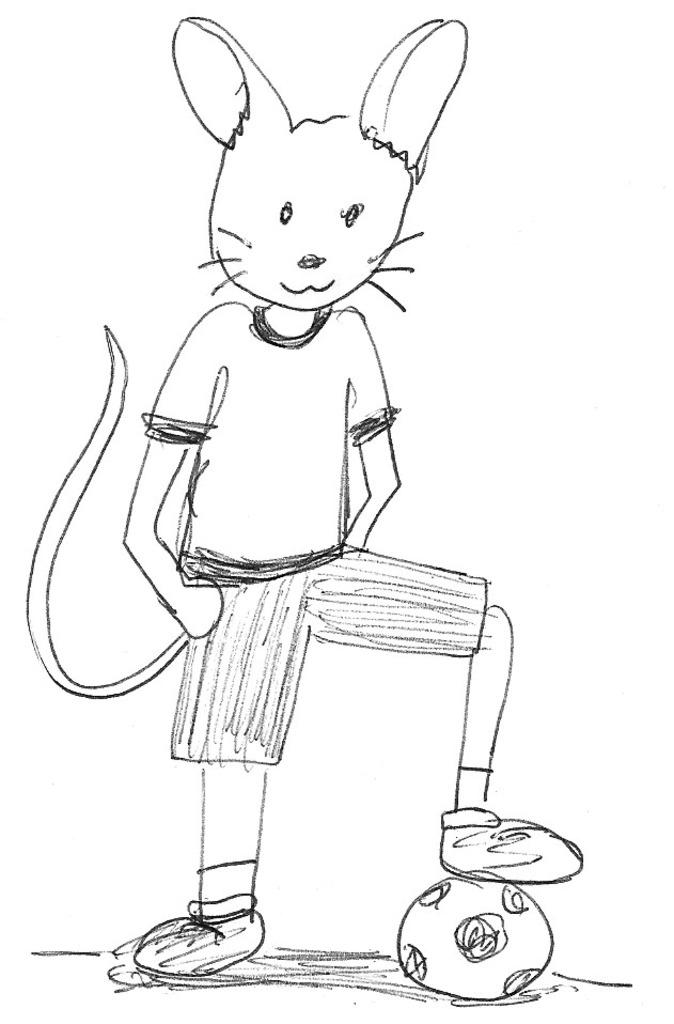What is the main subject of the picture? The main subject of the picture is an art of a cat face. What other object can be seen in the picture? There is a ball in the picture. What type of cheese is being displayed in the picture? There is no cheese present in the image; it features an art of a cat face and a ball. What show is being performed in the picture? There is no show being performed in the image; it only contains an art of a cat face and a ball. 